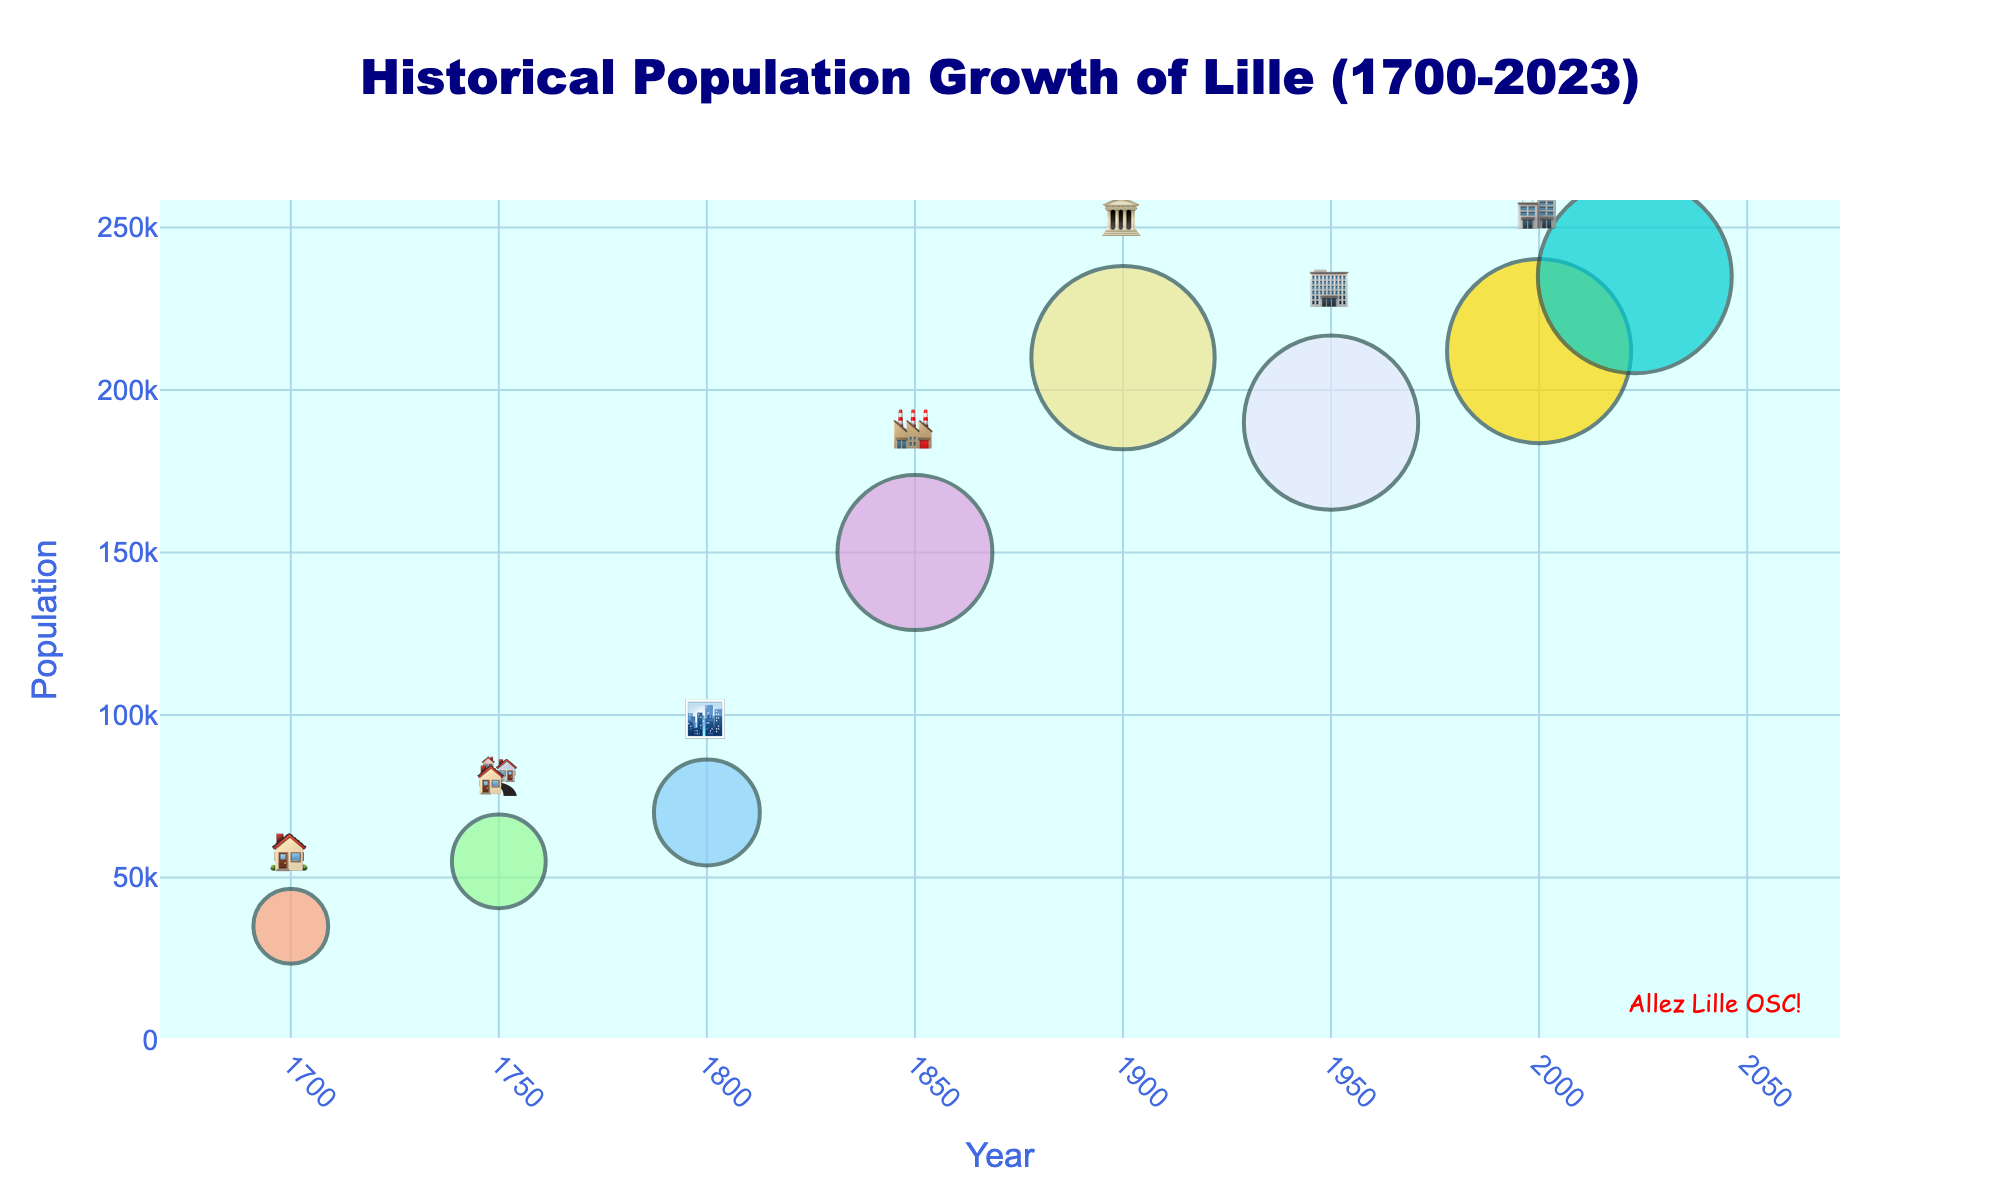What is the title of the figure? The title appears at the top of the figure in a larger font and usually summarizes the content. In this case, it reads "Historical Population Growth of Lille (1700-2023)".
Answer: Historical Population Growth of Lille (1700-2023) What do the building emojis represent in the figure? The building emojis are positioned as labels near each data point, representing different periods in Lille's growth and development from residential to industrial and beyond.
Answer: Different periods in Lille's growth Which year shows the lowest population in the figure? By examining the y-axis and the data points, the year with the lowest population is marked with the earliest emoji. In this case, it is 1700.
Answer: 1700 What is the population of Lille in the year 1850? Locate the data point for the year 1850 on the x-axis and refer to its corresponding y-value for the population.
Answer: 150,000 Which year had a significant population decrease compared to its previous data point, and what was the approximate population before and after the decrease? Identify points where the population decreases instead of increasing. From 1900 to 1950, the population decreased from about 210,000 to 190,000.
Answer: 1950, 210,000 to 190,000 How much did the population of Lille increase from 2000 to 2023? Subtract the population of the year 2000 from the population of 2023. The population increased from 212,000 to 235,000.
Answer: 23,000 Which time period saw the highest population growth in Lille? Look for the data point where the slope between two consecutive years is steepest. Between 1800 and 1850, the population increased significantly from 70,000 to 150,000.
Answer: 1800 to 1850 What is the average population of Lille across all years in the figure? Sum the populations for all years provided and then divide by the total number of years. (35,000 + 55,000 + 70,000 + 150,000 + 210,000 + 190,000 + 212,000 + 235,000) / 8 ~= 144,625
Answer: 144,625 Between which two consecutive time points did Lille's population remain almost stable? Identify the two consecutive points where the population change is minimal. Between 1900 and 1950, the population remains stable around 210,000 and 190,000.
Answer: 1900 to 1950 What color scheme is used in the markers for the data points? The colors used can be identified by examining the shades of the markers directly on the plot, represented in various distinct hues.
Answer: Various shades from warm to cool colors 